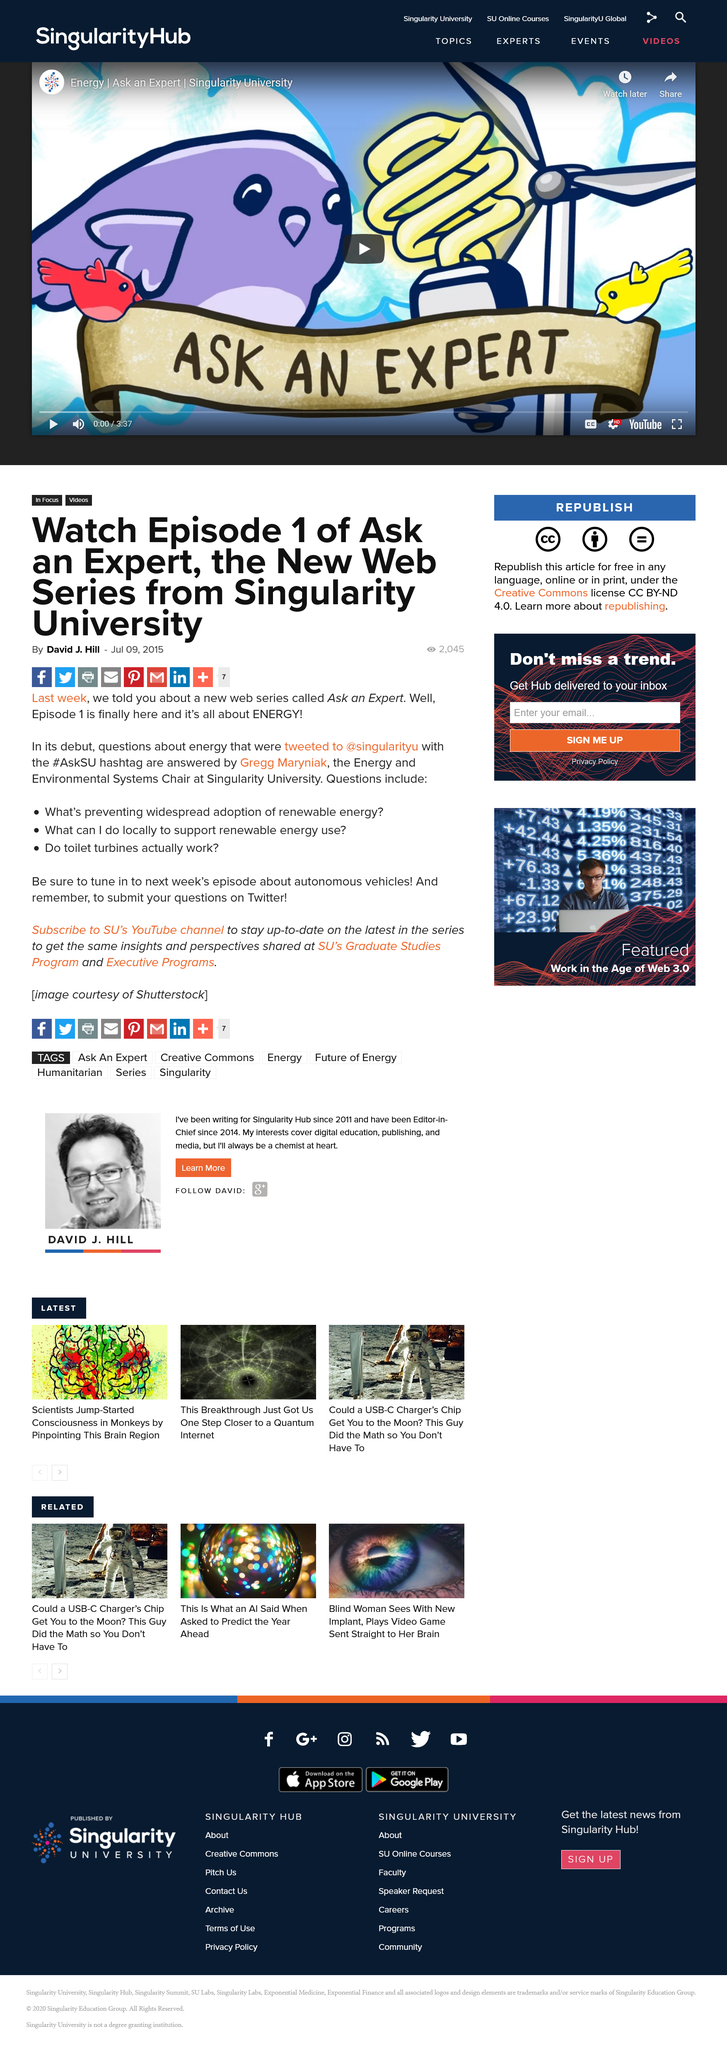Mention a couple of crucial points in this snapshot. One of the questions asked during the meeting was whether toilet turbines are effective. The tweets were sent to the handle @singularityu, which contained inquiries about energy. The debut of Ask an Expert saw Gregg Maryniak answering questions. 